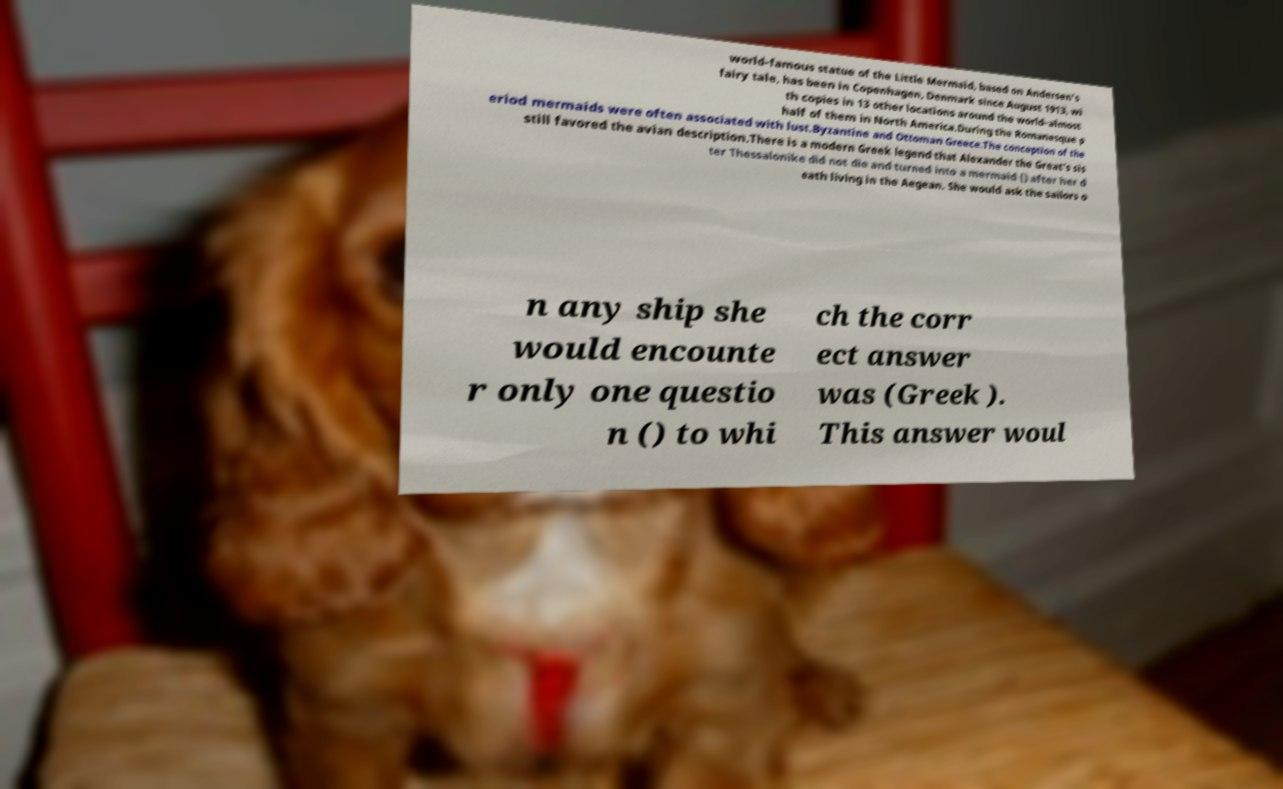Please read and relay the text visible in this image. What does it say? world-famous statue of the Little Mermaid, based on Andersen's fairy tale, has been in Copenhagen, Denmark since August 1913, wi th copies in 13 other locations around the world–almost half of them in North America.During the Romanesque p eriod mermaids were often associated with lust.Byzantine and Ottoman Greece.The conception of the still favored the avian description.There is a modern Greek legend that Alexander the Great's sis ter Thessalonike did not die and turned into a mermaid () after her d eath living in the Aegean. She would ask the sailors o n any ship she would encounte r only one questio n () to whi ch the corr ect answer was (Greek ). This answer woul 